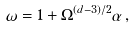Convert formula to latex. <formula><loc_0><loc_0><loc_500><loc_500>\omega = 1 + \Omega ^ { ( d - 3 ) / 2 } \alpha \, ,</formula> 